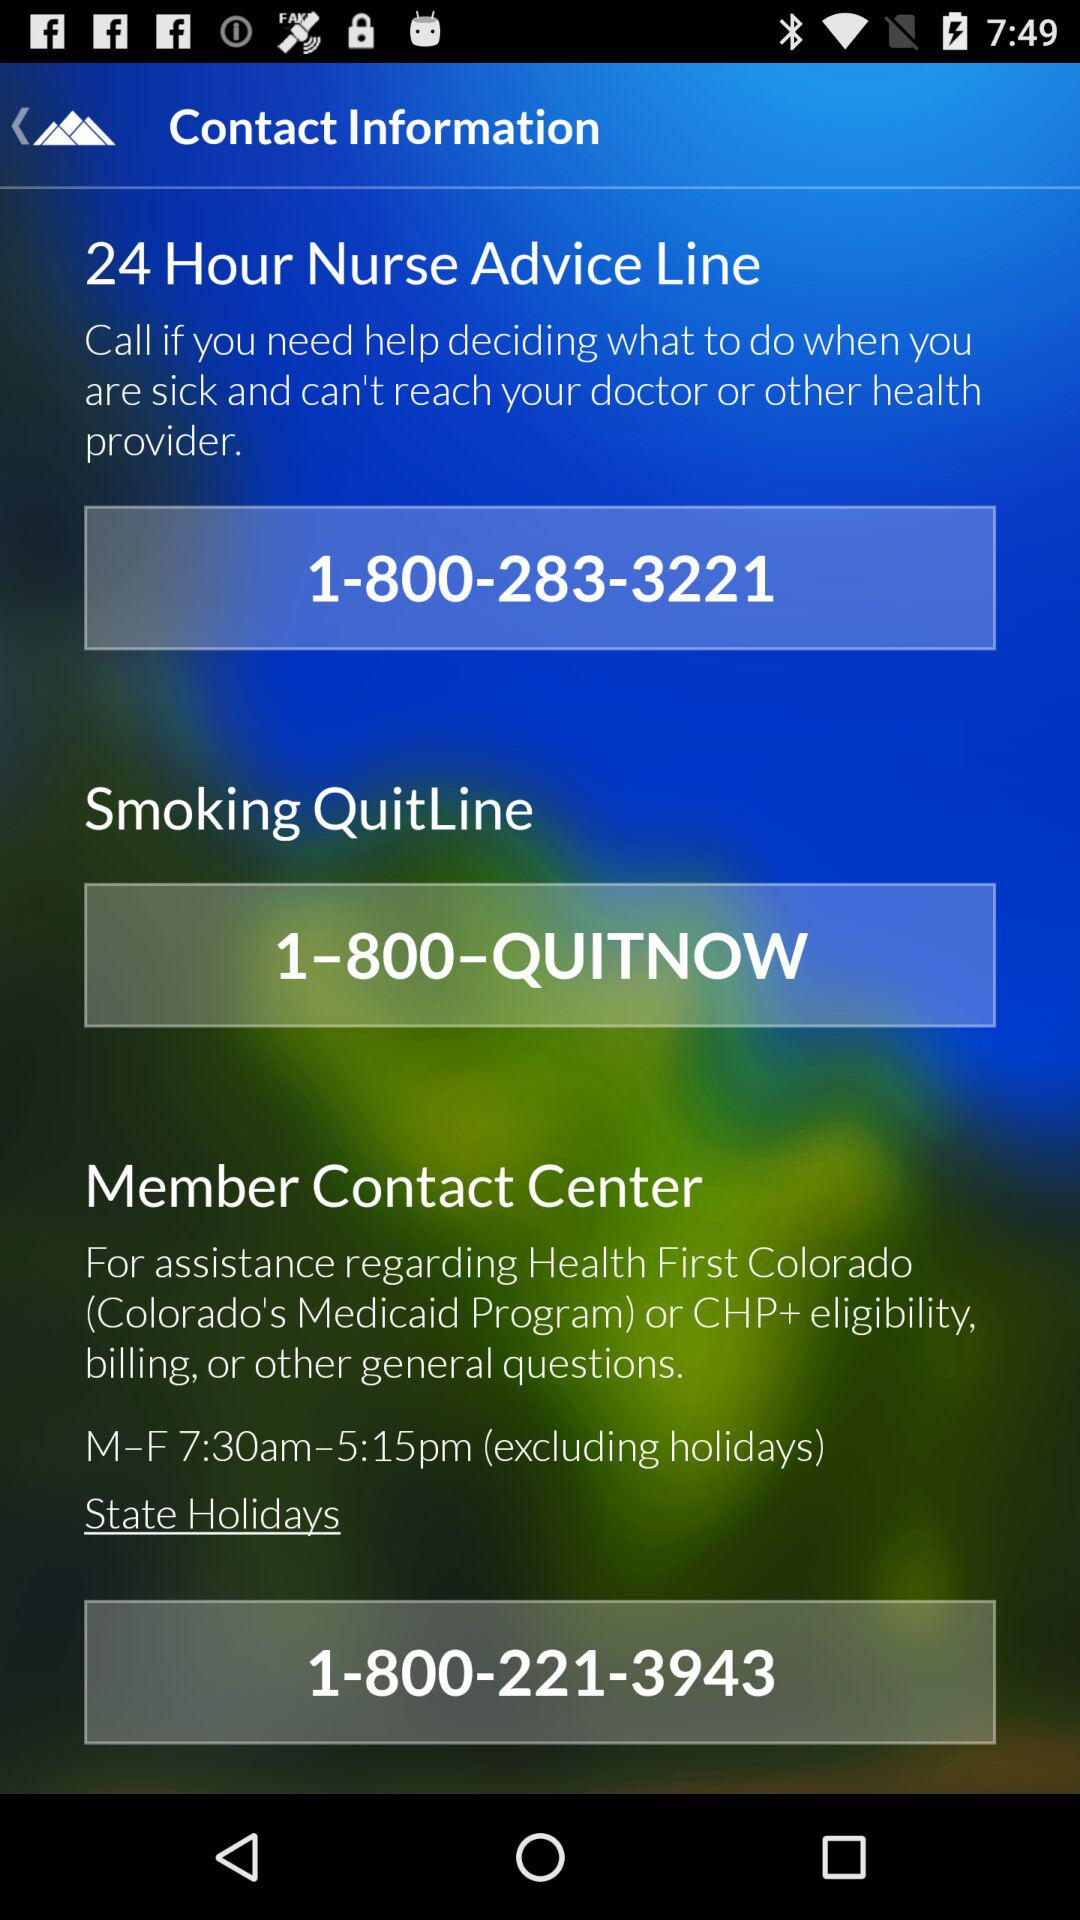What are the opening and closing hours of the Member Contact Center? The opening and closing hours of the Member Contact Center are 7:30am and 5:15pm. 